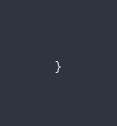<code> <loc_0><loc_0><loc_500><loc_500><_JavaScript_>}
</code> 